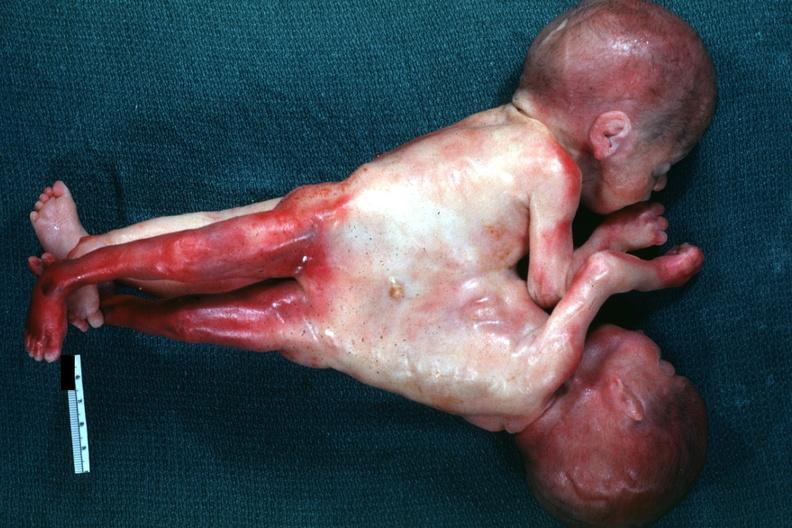does siamese twins show very good example joined abdomen and lower chest anterior?
Answer the question using a single word or phrase. No 